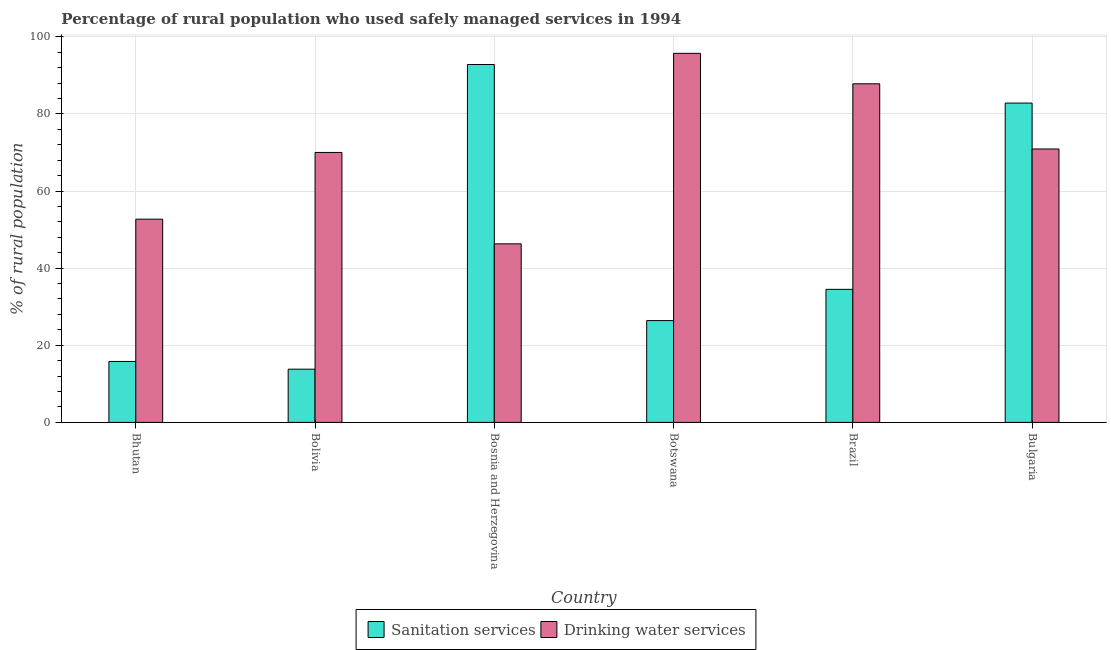How many bars are there on the 4th tick from the left?
Ensure brevity in your answer.  2. How many bars are there on the 2nd tick from the right?
Make the answer very short. 2. In how many cases, is the number of bars for a given country not equal to the number of legend labels?
Your response must be concise. 0. What is the percentage of rural population who used sanitation services in Brazil?
Keep it short and to the point. 34.5. Across all countries, what is the maximum percentage of rural population who used drinking water services?
Your response must be concise. 95.7. Across all countries, what is the minimum percentage of rural population who used sanitation services?
Keep it short and to the point. 13.8. In which country was the percentage of rural population who used sanitation services maximum?
Provide a succinct answer. Bosnia and Herzegovina. In which country was the percentage of rural population who used drinking water services minimum?
Offer a terse response. Bosnia and Herzegovina. What is the total percentage of rural population who used drinking water services in the graph?
Your response must be concise. 423.4. What is the difference between the percentage of rural population who used sanitation services in Bolivia and that in Bulgaria?
Your answer should be compact. -69. What is the difference between the percentage of rural population who used sanitation services in Bolivia and the percentage of rural population who used drinking water services in Bulgaria?
Ensure brevity in your answer.  -57.1. What is the average percentage of rural population who used drinking water services per country?
Your answer should be compact. 70.57. What is the difference between the percentage of rural population who used drinking water services and percentage of rural population who used sanitation services in Bhutan?
Offer a terse response. 36.9. What is the ratio of the percentage of rural population who used drinking water services in Botswana to that in Brazil?
Your answer should be compact. 1.09. Is the percentage of rural population who used sanitation services in Bosnia and Herzegovina less than that in Brazil?
Offer a very short reply. No. Is the difference between the percentage of rural population who used sanitation services in Bosnia and Herzegovina and Botswana greater than the difference between the percentage of rural population who used drinking water services in Bosnia and Herzegovina and Botswana?
Your answer should be very brief. Yes. What is the difference between the highest and the second highest percentage of rural population who used drinking water services?
Offer a terse response. 7.9. What is the difference between the highest and the lowest percentage of rural population who used drinking water services?
Provide a short and direct response. 49.4. In how many countries, is the percentage of rural population who used sanitation services greater than the average percentage of rural population who used sanitation services taken over all countries?
Provide a short and direct response. 2. What does the 1st bar from the left in Bhutan represents?
Keep it short and to the point. Sanitation services. What does the 1st bar from the right in Bolivia represents?
Provide a succinct answer. Drinking water services. What is the difference between two consecutive major ticks on the Y-axis?
Keep it short and to the point. 20. Does the graph contain any zero values?
Provide a succinct answer. No. Where does the legend appear in the graph?
Give a very brief answer. Bottom center. How many legend labels are there?
Provide a succinct answer. 2. What is the title of the graph?
Ensure brevity in your answer.  Percentage of rural population who used safely managed services in 1994. What is the label or title of the X-axis?
Offer a terse response. Country. What is the label or title of the Y-axis?
Give a very brief answer. % of rural population. What is the % of rural population of Drinking water services in Bhutan?
Keep it short and to the point. 52.7. What is the % of rural population of Sanitation services in Bosnia and Herzegovina?
Keep it short and to the point. 92.8. What is the % of rural population of Drinking water services in Bosnia and Herzegovina?
Offer a very short reply. 46.3. What is the % of rural population of Sanitation services in Botswana?
Provide a succinct answer. 26.4. What is the % of rural population of Drinking water services in Botswana?
Make the answer very short. 95.7. What is the % of rural population in Sanitation services in Brazil?
Offer a terse response. 34.5. What is the % of rural population in Drinking water services in Brazil?
Give a very brief answer. 87.8. What is the % of rural population of Sanitation services in Bulgaria?
Your response must be concise. 82.8. What is the % of rural population in Drinking water services in Bulgaria?
Make the answer very short. 70.9. Across all countries, what is the maximum % of rural population of Sanitation services?
Ensure brevity in your answer.  92.8. Across all countries, what is the maximum % of rural population of Drinking water services?
Provide a short and direct response. 95.7. Across all countries, what is the minimum % of rural population of Drinking water services?
Give a very brief answer. 46.3. What is the total % of rural population of Sanitation services in the graph?
Your answer should be compact. 266.1. What is the total % of rural population of Drinking water services in the graph?
Your answer should be very brief. 423.4. What is the difference between the % of rural population of Drinking water services in Bhutan and that in Bolivia?
Make the answer very short. -17.3. What is the difference between the % of rural population of Sanitation services in Bhutan and that in Bosnia and Herzegovina?
Ensure brevity in your answer.  -77. What is the difference between the % of rural population of Sanitation services in Bhutan and that in Botswana?
Make the answer very short. -10.6. What is the difference between the % of rural population of Drinking water services in Bhutan and that in Botswana?
Provide a succinct answer. -43. What is the difference between the % of rural population in Sanitation services in Bhutan and that in Brazil?
Keep it short and to the point. -18.7. What is the difference between the % of rural population in Drinking water services in Bhutan and that in Brazil?
Make the answer very short. -35.1. What is the difference between the % of rural population in Sanitation services in Bhutan and that in Bulgaria?
Provide a short and direct response. -67. What is the difference between the % of rural population of Drinking water services in Bhutan and that in Bulgaria?
Provide a succinct answer. -18.2. What is the difference between the % of rural population in Sanitation services in Bolivia and that in Bosnia and Herzegovina?
Your answer should be very brief. -79. What is the difference between the % of rural population in Drinking water services in Bolivia and that in Bosnia and Herzegovina?
Provide a succinct answer. 23.7. What is the difference between the % of rural population of Drinking water services in Bolivia and that in Botswana?
Make the answer very short. -25.7. What is the difference between the % of rural population in Sanitation services in Bolivia and that in Brazil?
Offer a very short reply. -20.7. What is the difference between the % of rural population in Drinking water services in Bolivia and that in Brazil?
Ensure brevity in your answer.  -17.8. What is the difference between the % of rural population in Sanitation services in Bolivia and that in Bulgaria?
Provide a short and direct response. -69. What is the difference between the % of rural population of Drinking water services in Bolivia and that in Bulgaria?
Make the answer very short. -0.9. What is the difference between the % of rural population of Sanitation services in Bosnia and Herzegovina and that in Botswana?
Offer a very short reply. 66.4. What is the difference between the % of rural population of Drinking water services in Bosnia and Herzegovina and that in Botswana?
Offer a terse response. -49.4. What is the difference between the % of rural population of Sanitation services in Bosnia and Herzegovina and that in Brazil?
Your answer should be very brief. 58.3. What is the difference between the % of rural population of Drinking water services in Bosnia and Herzegovina and that in Brazil?
Provide a succinct answer. -41.5. What is the difference between the % of rural population in Drinking water services in Bosnia and Herzegovina and that in Bulgaria?
Provide a succinct answer. -24.6. What is the difference between the % of rural population in Drinking water services in Botswana and that in Brazil?
Give a very brief answer. 7.9. What is the difference between the % of rural population in Sanitation services in Botswana and that in Bulgaria?
Keep it short and to the point. -56.4. What is the difference between the % of rural population of Drinking water services in Botswana and that in Bulgaria?
Make the answer very short. 24.8. What is the difference between the % of rural population in Sanitation services in Brazil and that in Bulgaria?
Your answer should be compact. -48.3. What is the difference between the % of rural population of Drinking water services in Brazil and that in Bulgaria?
Ensure brevity in your answer.  16.9. What is the difference between the % of rural population in Sanitation services in Bhutan and the % of rural population in Drinking water services in Bolivia?
Offer a very short reply. -54.2. What is the difference between the % of rural population in Sanitation services in Bhutan and the % of rural population in Drinking water services in Bosnia and Herzegovina?
Offer a very short reply. -30.5. What is the difference between the % of rural population in Sanitation services in Bhutan and the % of rural population in Drinking water services in Botswana?
Provide a short and direct response. -79.9. What is the difference between the % of rural population of Sanitation services in Bhutan and the % of rural population of Drinking water services in Brazil?
Your answer should be compact. -72. What is the difference between the % of rural population of Sanitation services in Bhutan and the % of rural population of Drinking water services in Bulgaria?
Offer a very short reply. -55.1. What is the difference between the % of rural population in Sanitation services in Bolivia and the % of rural population in Drinking water services in Bosnia and Herzegovina?
Provide a succinct answer. -32.5. What is the difference between the % of rural population in Sanitation services in Bolivia and the % of rural population in Drinking water services in Botswana?
Provide a short and direct response. -81.9. What is the difference between the % of rural population in Sanitation services in Bolivia and the % of rural population in Drinking water services in Brazil?
Give a very brief answer. -74. What is the difference between the % of rural population of Sanitation services in Bolivia and the % of rural population of Drinking water services in Bulgaria?
Your answer should be compact. -57.1. What is the difference between the % of rural population in Sanitation services in Bosnia and Herzegovina and the % of rural population in Drinking water services in Bulgaria?
Keep it short and to the point. 21.9. What is the difference between the % of rural population in Sanitation services in Botswana and the % of rural population in Drinking water services in Brazil?
Offer a very short reply. -61.4. What is the difference between the % of rural population of Sanitation services in Botswana and the % of rural population of Drinking water services in Bulgaria?
Keep it short and to the point. -44.5. What is the difference between the % of rural population of Sanitation services in Brazil and the % of rural population of Drinking water services in Bulgaria?
Your answer should be very brief. -36.4. What is the average % of rural population in Sanitation services per country?
Provide a short and direct response. 44.35. What is the average % of rural population in Drinking water services per country?
Ensure brevity in your answer.  70.57. What is the difference between the % of rural population of Sanitation services and % of rural population of Drinking water services in Bhutan?
Provide a short and direct response. -36.9. What is the difference between the % of rural population in Sanitation services and % of rural population in Drinking water services in Bolivia?
Your answer should be very brief. -56.2. What is the difference between the % of rural population of Sanitation services and % of rural population of Drinking water services in Bosnia and Herzegovina?
Provide a succinct answer. 46.5. What is the difference between the % of rural population in Sanitation services and % of rural population in Drinking water services in Botswana?
Keep it short and to the point. -69.3. What is the difference between the % of rural population of Sanitation services and % of rural population of Drinking water services in Brazil?
Offer a terse response. -53.3. What is the ratio of the % of rural population in Sanitation services in Bhutan to that in Bolivia?
Your answer should be very brief. 1.14. What is the ratio of the % of rural population of Drinking water services in Bhutan to that in Bolivia?
Provide a succinct answer. 0.75. What is the ratio of the % of rural population of Sanitation services in Bhutan to that in Bosnia and Herzegovina?
Your answer should be very brief. 0.17. What is the ratio of the % of rural population of Drinking water services in Bhutan to that in Bosnia and Herzegovina?
Keep it short and to the point. 1.14. What is the ratio of the % of rural population of Sanitation services in Bhutan to that in Botswana?
Give a very brief answer. 0.6. What is the ratio of the % of rural population in Drinking water services in Bhutan to that in Botswana?
Your response must be concise. 0.55. What is the ratio of the % of rural population in Sanitation services in Bhutan to that in Brazil?
Your response must be concise. 0.46. What is the ratio of the % of rural population of Drinking water services in Bhutan to that in Brazil?
Provide a short and direct response. 0.6. What is the ratio of the % of rural population of Sanitation services in Bhutan to that in Bulgaria?
Provide a succinct answer. 0.19. What is the ratio of the % of rural population in Drinking water services in Bhutan to that in Bulgaria?
Make the answer very short. 0.74. What is the ratio of the % of rural population in Sanitation services in Bolivia to that in Bosnia and Herzegovina?
Ensure brevity in your answer.  0.15. What is the ratio of the % of rural population in Drinking water services in Bolivia to that in Bosnia and Herzegovina?
Keep it short and to the point. 1.51. What is the ratio of the % of rural population of Sanitation services in Bolivia to that in Botswana?
Offer a terse response. 0.52. What is the ratio of the % of rural population of Drinking water services in Bolivia to that in Botswana?
Provide a succinct answer. 0.73. What is the ratio of the % of rural population in Sanitation services in Bolivia to that in Brazil?
Make the answer very short. 0.4. What is the ratio of the % of rural population in Drinking water services in Bolivia to that in Brazil?
Your answer should be compact. 0.8. What is the ratio of the % of rural population in Drinking water services in Bolivia to that in Bulgaria?
Your response must be concise. 0.99. What is the ratio of the % of rural population of Sanitation services in Bosnia and Herzegovina to that in Botswana?
Your response must be concise. 3.52. What is the ratio of the % of rural population of Drinking water services in Bosnia and Herzegovina to that in Botswana?
Your answer should be compact. 0.48. What is the ratio of the % of rural population of Sanitation services in Bosnia and Herzegovina to that in Brazil?
Your answer should be very brief. 2.69. What is the ratio of the % of rural population of Drinking water services in Bosnia and Herzegovina to that in Brazil?
Make the answer very short. 0.53. What is the ratio of the % of rural population of Sanitation services in Bosnia and Herzegovina to that in Bulgaria?
Provide a short and direct response. 1.12. What is the ratio of the % of rural population in Drinking water services in Bosnia and Herzegovina to that in Bulgaria?
Your answer should be very brief. 0.65. What is the ratio of the % of rural population in Sanitation services in Botswana to that in Brazil?
Offer a very short reply. 0.77. What is the ratio of the % of rural population in Drinking water services in Botswana to that in Brazil?
Provide a short and direct response. 1.09. What is the ratio of the % of rural population of Sanitation services in Botswana to that in Bulgaria?
Ensure brevity in your answer.  0.32. What is the ratio of the % of rural population in Drinking water services in Botswana to that in Bulgaria?
Ensure brevity in your answer.  1.35. What is the ratio of the % of rural population in Sanitation services in Brazil to that in Bulgaria?
Your answer should be very brief. 0.42. What is the ratio of the % of rural population in Drinking water services in Brazil to that in Bulgaria?
Your response must be concise. 1.24. What is the difference between the highest and the second highest % of rural population in Sanitation services?
Your answer should be compact. 10. What is the difference between the highest and the lowest % of rural population in Sanitation services?
Ensure brevity in your answer.  79. What is the difference between the highest and the lowest % of rural population of Drinking water services?
Offer a very short reply. 49.4. 